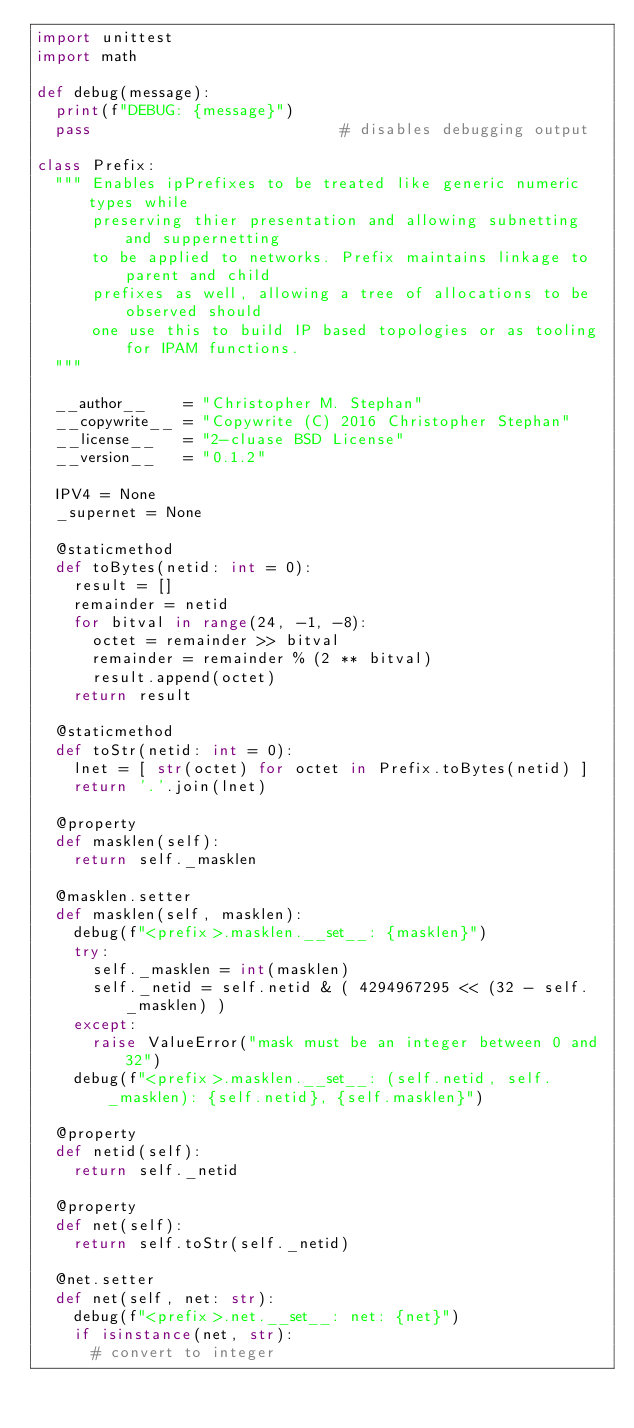Convert code to text. <code><loc_0><loc_0><loc_500><loc_500><_Python_>import unittest
import math

def debug(message):
	print(f"DEBUG: {message}")
	pass                           # disables debugging output

class Prefix:
	""" Enables ipPrefixes to be treated like generic numeric types while
	    preserving thier presentation and allowing subnetting and suppernetting
	    to be applied to networks. Prefix maintains linkage to parent and child
	    prefixes as well, allowing a tree of allocations to be observed should
	    one use this to build IP based topologies or as tooling for IPAM functions.
	"""
	
	__author__    = "Christopher M. Stephan"
	__copywrite__ = "Copywrite (C) 2016 Christopher Stephan"  
	__license__   = "2-cluase BSD License"
	__version__   = "0.1.2"
	    
	IPV4 = None
	_supernet = None
	
	@staticmethod
	def toBytes(netid: int = 0):
		result = []
		remainder = netid
		for bitval in range(24, -1, -8):
			octet = remainder >> bitval
			remainder = remainder % (2 ** bitval)
			result.append(octet)
		return result
		
	@staticmethod
	def toStr(netid: int = 0):
		lnet = [ str(octet) for octet in Prefix.toBytes(netid) ]
		return '.'.join(lnet)
		
	@property
	def masklen(self):
		return self._masklen
		
	@masklen.setter
	def masklen(self, masklen):
		debug(f"<prefix>.masklen.__set__: {masklen}")
		try:
			self._masklen = int(masklen)
			self._netid = self.netid & ( 4294967295 << (32 - self._masklen) )
		except:
			raise ValueError("mask must be an integer between 0 and 32")
		debug(f"<prefix>.masklen.__set__: (self.netid, self._masklen): {self.netid}, {self.masklen}")
	
	@property
	def netid(self):
		return self._netid
		
	@property
	def net(self):
		return self.toStr(self._netid)
		
	@net.setter
	def net(self, net: str):
		debug(f"<prefix>.net.__set__: net: {net}")
		if isinstance(net, str):
			# convert to integer</code> 